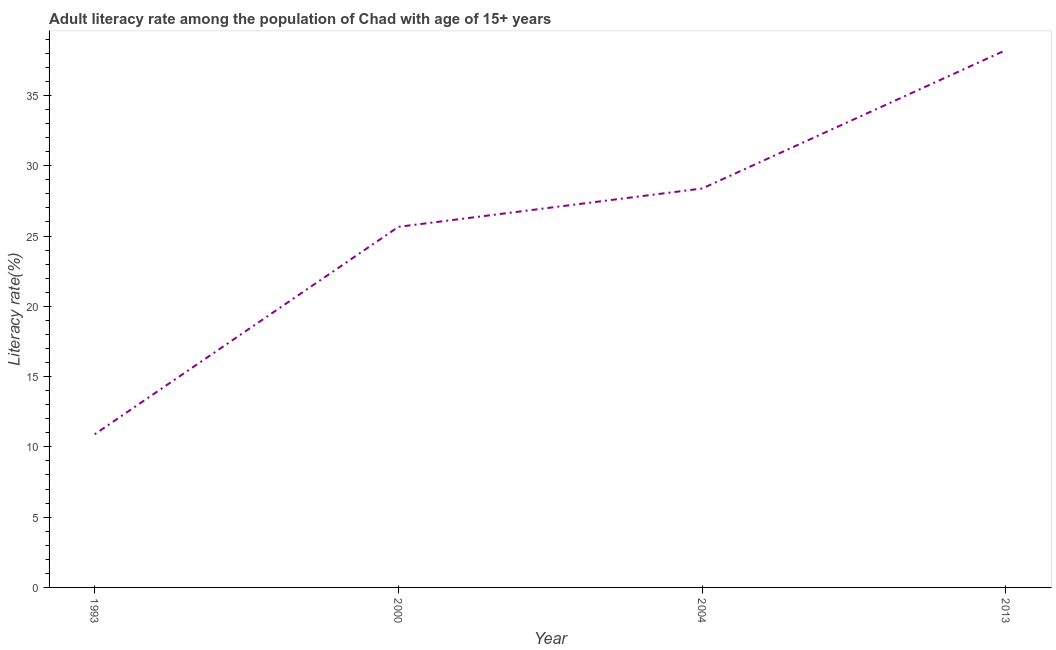What is the adult literacy rate in 1993?
Provide a short and direct response. 10.89. Across all years, what is the maximum adult literacy rate?
Make the answer very short. 38.23. Across all years, what is the minimum adult literacy rate?
Keep it short and to the point. 10.89. In which year was the adult literacy rate maximum?
Ensure brevity in your answer.  2013. What is the sum of the adult literacy rate?
Offer a very short reply. 103.16. What is the difference between the adult literacy rate in 1993 and 2013?
Provide a succinct answer. -27.34. What is the average adult literacy rate per year?
Your response must be concise. 25.79. What is the median adult literacy rate?
Ensure brevity in your answer.  27.02. In how many years, is the adult literacy rate greater than 22 %?
Make the answer very short. 3. What is the ratio of the adult literacy rate in 2000 to that in 2013?
Your response must be concise. 0.67. Is the adult literacy rate in 2000 less than that in 2013?
Your response must be concise. Yes. Is the difference between the adult literacy rate in 1993 and 2004 greater than the difference between any two years?
Provide a succinct answer. No. What is the difference between the highest and the second highest adult literacy rate?
Offer a very short reply. 9.85. Is the sum of the adult literacy rate in 2000 and 2004 greater than the maximum adult literacy rate across all years?
Provide a short and direct response. Yes. What is the difference between the highest and the lowest adult literacy rate?
Provide a short and direct response. 27.34. In how many years, is the adult literacy rate greater than the average adult literacy rate taken over all years?
Offer a very short reply. 2. Does the adult literacy rate monotonically increase over the years?
Your response must be concise. Yes. How many lines are there?
Your answer should be compact. 1. What is the difference between two consecutive major ticks on the Y-axis?
Your answer should be compact. 5. Are the values on the major ticks of Y-axis written in scientific E-notation?
Keep it short and to the point. No. Does the graph contain grids?
Your response must be concise. No. What is the title of the graph?
Your answer should be very brief. Adult literacy rate among the population of Chad with age of 15+ years. What is the label or title of the X-axis?
Your answer should be very brief. Year. What is the label or title of the Y-axis?
Offer a terse response. Literacy rate(%). What is the Literacy rate(%) in 1993?
Your answer should be compact. 10.89. What is the Literacy rate(%) of 2000?
Offer a terse response. 25.65. What is the Literacy rate(%) of 2004?
Keep it short and to the point. 28.38. What is the Literacy rate(%) of 2013?
Give a very brief answer. 38.23. What is the difference between the Literacy rate(%) in 1993 and 2000?
Keep it short and to the point. -14.76. What is the difference between the Literacy rate(%) in 1993 and 2004?
Make the answer very short. -17.49. What is the difference between the Literacy rate(%) in 1993 and 2013?
Your answer should be very brief. -27.34. What is the difference between the Literacy rate(%) in 2000 and 2004?
Your response must be concise. -2.73. What is the difference between the Literacy rate(%) in 2000 and 2013?
Offer a terse response. -12.58. What is the difference between the Literacy rate(%) in 2004 and 2013?
Offer a terse response. -9.85. What is the ratio of the Literacy rate(%) in 1993 to that in 2000?
Provide a short and direct response. 0.42. What is the ratio of the Literacy rate(%) in 1993 to that in 2004?
Ensure brevity in your answer.  0.38. What is the ratio of the Literacy rate(%) in 1993 to that in 2013?
Your response must be concise. 0.28. What is the ratio of the Literacy rate(%) in 2000 to that in 2004?
Offer a very short reply. 0.9. What is the ratio of the Literacy rate(%) in 2000 to that in 2013?
Offer a very short reply. 0.67. What is the ratio of the Literacy rate(%) in 2004 to that in 2013?
Keep it short and to the point. 0.74. 